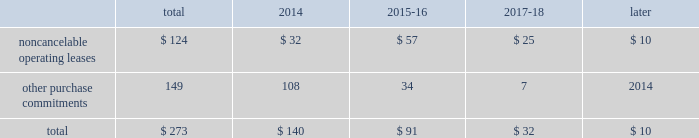23t .
Rowe price group | annual report 2013 contractual obligations the table presents a summary of our future obligations ( in millions ) under the terms of existing operating leases and other contractual cash purchase commitments at december 31 , 2013 .
Other purchase commitments include contractual amounts that will be due for the purchase of goods or services to be used in our operations and may be cancelable at earlier times than those indicated , under certain conditions that may involve termination fees .
Because these obligations are generally of a normal recurring nature , we expect that we will fund them from future cash flows from operations .
The information presented does not include operating expenses or capital expenditures that will be committed in the normal course of operations in 2014 and future years .
The information also excludes the $ 4.8 million of uncertain tax positions discussed in note 8 to our consolidated financial statements because it is not possible to estimate the time period in which a payment might be made to the tax authorities. .
We also have outstanding commitments to fund additional contributions to investment partnerships totaling $ 40.7 million at december 31 , 2013 .
The vast majority of these additional contributions will be made to investment partnerships in which we have an existing investment .
In addition to such amounts , a percentage of prior distributions may be called under certain circumstances .
In january 2014 , we renewed and extended our operating lease at our corporate headquarters in baltimore , maryland through 2027 .
This lease agreement increases the above disclosed total noncancelable operating lease commitments by an additional $ 133.0 million , the vast majority of which will be paid after 2018 .
Critical accounting policies the preparation of financial statements often requires the selection of specific accounting methods and policies from among several acceptable alternatives .
Further , significant estimates and judgments may be required in selecting and applying those methods and policies in the recognition of the assets and liabilities in our consolidated balance sheets , the revenues and expenses in our consolidated statements of income , and the information that is contained in our significant accounting policies and notes to consolidated financial statements .
Making these estimates and judgments requires the analysis of information concerning events that may not yet be complete and of facts and circumstances that may change over time .
Accordingly , actual amounts or future results can differ materially from those estimates that we include currently in our consolidated financial statements , significant accounting policies , and notes .
We present those significant accounting policies used in the preparation of our consolidated financial statements as an integral part of those statements within this 2013 annual report .
In the following discussion , we highlight and explain further certain of those policies that are most critical to the preparation and understanding of our financial statements .
Other-than-temporary impairments of available-for-sale securities .
We generally classify our investment holdings in sponsored funds as available-for-sale if we are not deemed to a have a controlling financial interest .
At the end of each quarter , we mark the carrying amount of each investment holding to fair value and recognize an unrealized gain or loss as a component of comprehensive income within the consolidated statements of comprehensive income .
We next review each individual security position that has an unrealized loss or impairment to determine if that impairment is other than temporary .
In determining whether a mutual fund holding is other-than-temporarily impaired , we consider many factors , including the duration of time it has existed , the severity of the impairment , any subsequent changes in value , and our intent and ability to hold the security for a period of time sufficient for an anticipated recovery in fair value .
Subject to the other considerations noted above , we believe a fund holding with an unrealized loss that has persisted daily throughout the six months between quarter-ends is generally presumed to have an other-than-temporary impairment .
We may also recognize an other-than-temporary loss of less than six months in our consolidated statements of income if the particular circumstances of the underlying investment do not warrant our belief that a near-term recovery is possible. .
Taking into account the renewal of the lease on corporate headquarters what would be the total contractual obligations due after 2018 in millions? 
Computations: (10 + 133.0)
Answer: 143.0. 